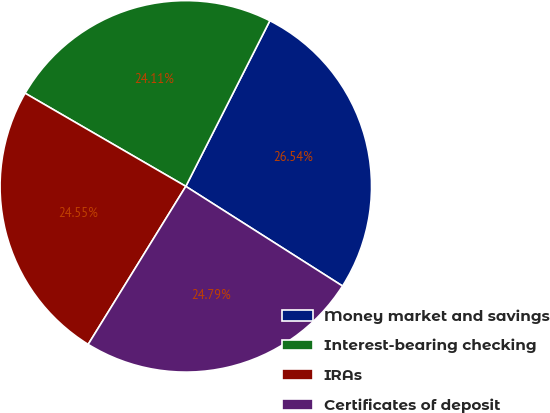<chart> <loc_0><loc_0><loc_500><loc_500><pie_chart><fcel>Money market and savings<fcel>Interest-bearing checking<fcel>IRAs<fcel>Certificates of deposit<nl><fcel>26.54%<fcel>24.11%<fcel>24.55%<fcel>24.79%<nl></chart> 